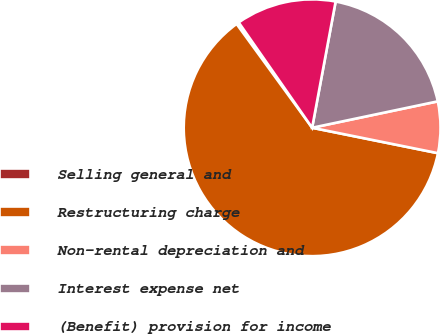Convert chart to OTSL. <chart><loc_0><loc_0><loc_500><loc_500><pie_chart><fcel>Selling general and<fcel>Restructuring charge<fcel>Non-rental depreciation and<fcel>Interest expense net<fcel>(Benefit) provision for income<nl><fcel>0.32%<fcel>61.81%<fcel>6.47%<fcel>18.77%<fcel>12.62%<nl></chart> 